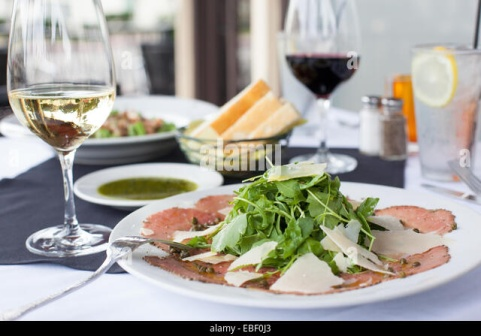If this image were part of a movie scene, what might the storyline be? In a film, this image could be part of a pivotal scene where two old friends reconnect after many years apart. Over a beautifully set table and fine wine, they recount their past adventures and the paths that led them to where they are now. The conversation starts light-hearted with stories of youthful escapades but gradually turns to deeper, more heartfelt reflections on missed opportunities, personal growth, and the importance of their friendship. The meal, rich with flavors and carefully paired wines, serves as a symbol of the depth and complexity of their relationship. As they share this moment, they both realize the enduring bond between them, setting the stage for a new chapter in their friendship. 